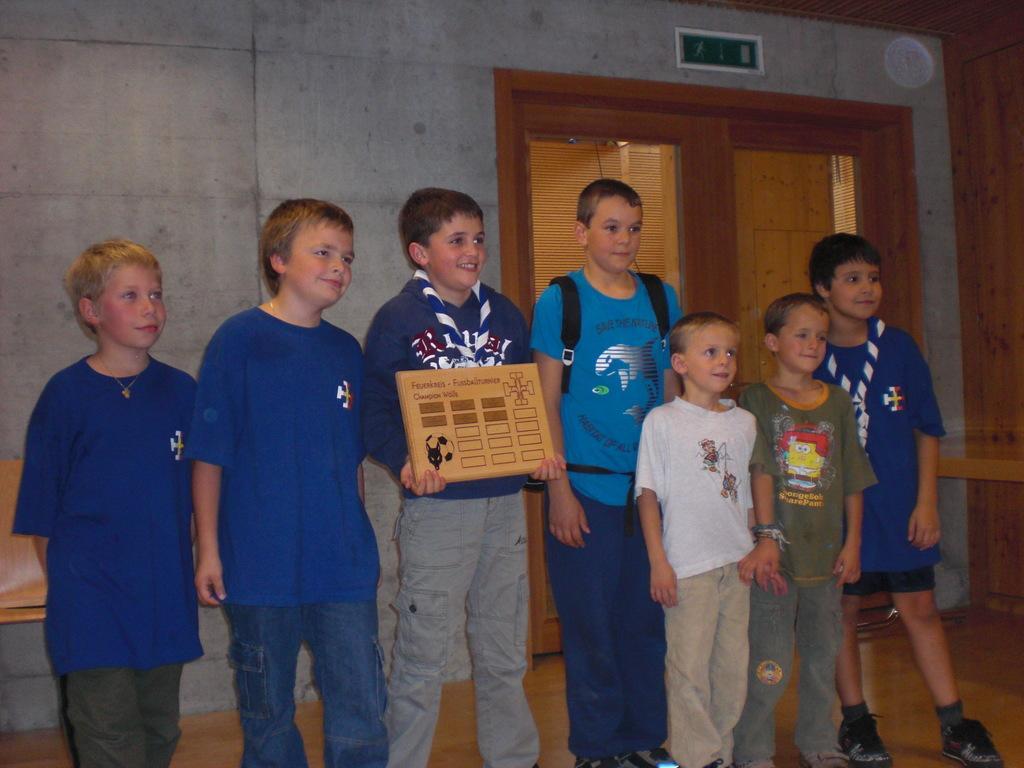How would you summarize this image in a sentence or two? In this image we can see people standing and in the middle we can see a person holding an object and behind them we can see a wall and a wooden door. 